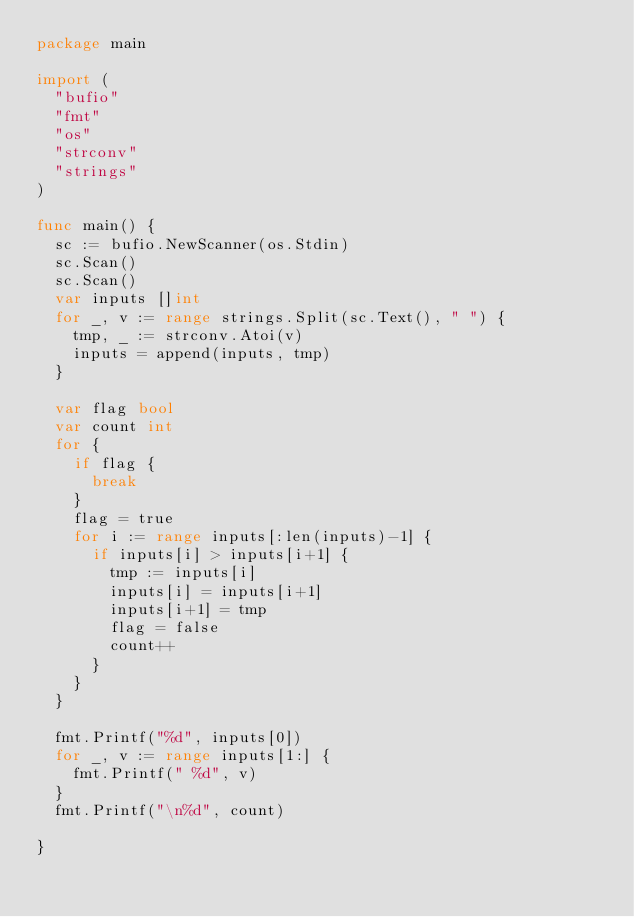Convert code to text. <code><loc_0><loc_0><loc_500><loc_500><_Go_>package main

import (
	"bufio"
	"fmt"
	"os"
	"strconv"
	"strings"
)

func main() {
	sc := bufio.NewScanner(os.Stdin)
	sc.Scan()
	sc.Scan()
	var inputs []int
	for _, v := range strings.Split(sc.Text(), " ") {
		tmp, _ := strconv.Atoi(v)
		inputs = append(inputs, tmp)
	}

	var flag bool
	var count int
	for {
		if flag {
			break
		}
		flag = true
		for i := range inputs[:len(inputs)-1] {
			if inputs[i] > inputs[i+1] {
				tmp := inputs[i]
				inputs[i] = inputs[i+1]
				inputs[i+1] = tmp
				flag = false
				count++
			}
		}
	}

	fmt.Printf("%d", inputs[0])
	for _, v := range inputs[1:] {
		fmt.Printf(" %d", v)
	}
	fmt.Printf("\n%d", count)

}

</code> 